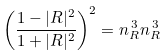<formula> <loc_0><loc_0><loc_500><loc_500>\left ( \frac { 1 - | R | ^ { 2 } } { 1 + | R | ^ { 2 } } \right ) ^ { 2 } = n _ { R } ^ { \, 3 } n _ { R } ^ { \, 3 }</formula> 